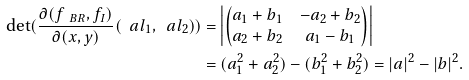Convert formula to latex. <formula><loc_0><loc_0><loc_500><loc_500>\det ( \frac { \partial ( f _ { \ B R } , f _ { I } ) } { \partial ( x , y ) } ( \ a l _ { 1 } , \ a l _ { 2 } ) ) & = \left | \left ( \begin{matrix} a _ { 1 } + b _ { 1 } & - a _ { 2 } + b _ { 2 } \\ a _ { 2 } + b _ { 2 } & a _ { 1 } - b _ { 1 } \end{matrix} \right ) \right | \\ & = ( a _ { 1 } ^ { 2 } + a _ { 2 } ^ { 2 } ) - ( b _ { 1 } ^ { 2 } + b _ { 2 } ^ { 2 } ) = | a | ^ { 2 } - | b | ^ { 2 } .</formula> 